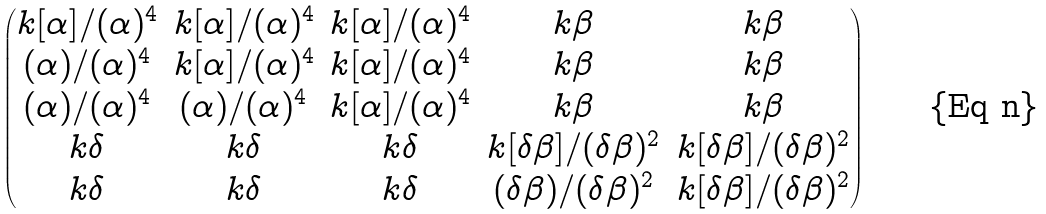<formula> <loc_0><loc_0><loc_500><loc_500>\begin{pmatrix} k [ \alpha ] / ( \alpha ) ^ { 4 } & k [ \alpha ] / ( \alpha ) ^ { 4 } & k [ \alpha ] / ( \alpha ) ^ { 4 } & k \beta & k \beta \\ ( \alpha ) / ( \alpha ) ^ { 4 } & k [ \alpha ] / ( \alpha ) ^ { 4 } & k [ \alpha ] / ( \alpha ) ^ { 4 } & k \beta & k \beta \\ ( \alpha ) / ( \alpha ) ^ { 4 } & ( \alpha ) / ( \alpha ) ^ { 4 } & k [ \alpha ] / ( \alpha ) ^ { 4 } & k \beta & k \beta \\ k \delta & k \delta & k \delta & k [ \delta \beta ] / ( \delta \beta ) ^ { 2 } & k [ \delta \beta ] / ( \delta \beta ) ^ { 2 } \\ k \delta & k \delta & k \delta & ( \delta \beta ) / ( \delta \beta ) ^ { 2 } & k [ \delta \beta ] / ( \delta \beta ) ^ { 2 } \\ \end{pmatrix}</formula> 